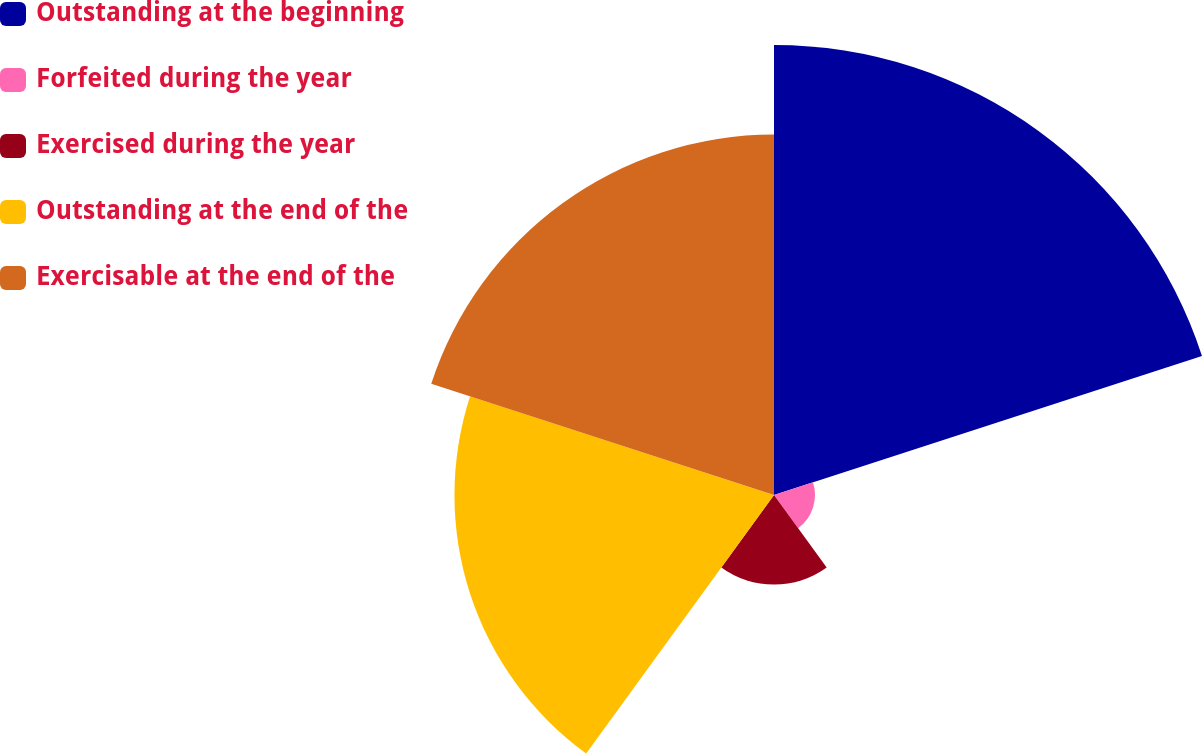<chart> <loc_0><loc_0><loc_500><loc_500><pie_chart><fcel>Outstanding at the beginning<fcel>Forfeited during the year<fcel>Exercised during the year<fcel>Outstanding at the end of the<fcel>Exercisable at the end of the<nl><fcel>35.7%<fcel>3.25%<fcel>7.11%<fcel>25.35%<fcel>28.59%<nl></chart> 